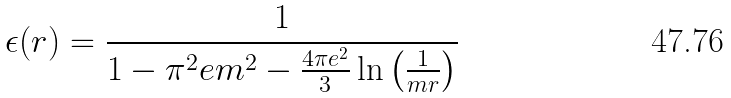<formula> <loc_0><loc_0><loc_500><loc_500>\epsilon ( r ) = \frac { 1 } { 1 - \pi ^ { 2 } e m ^ { 2 } - \frac { 4 \pi e ^ { 2 } } { 3 } \ln \left ( \frac { 1 } { m r } \right ) }</formula> 